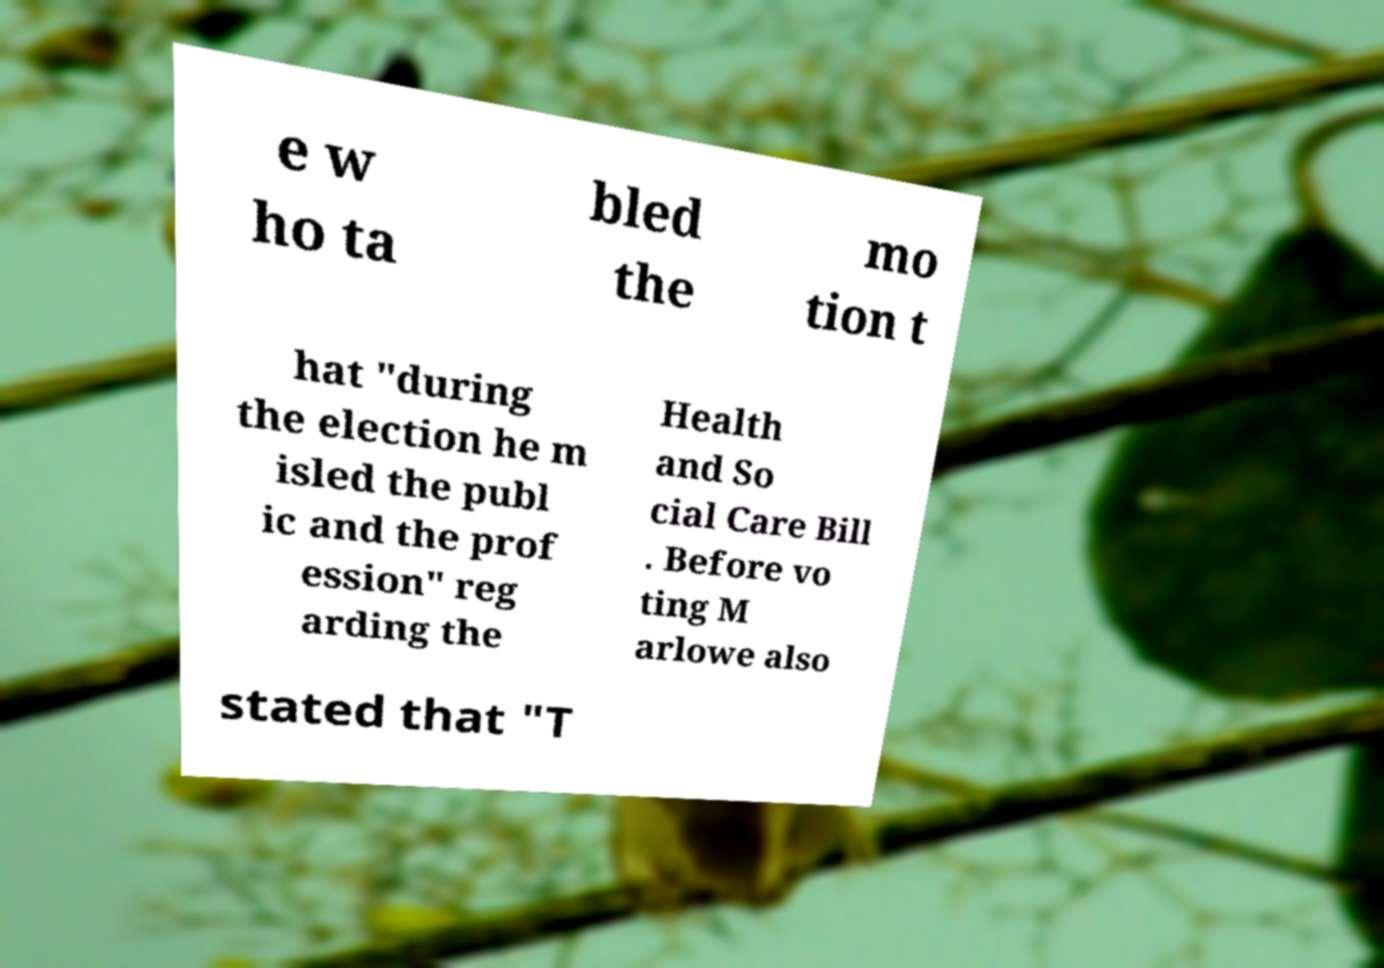Please identify and transcribe the text found in this image. e w ho ta bled the mo tion t hat "during the election he m isled the publ ic and the prof ession" reg arding the Health and So cial Care Bill . Before vo ting M arlowe also stated that "T 